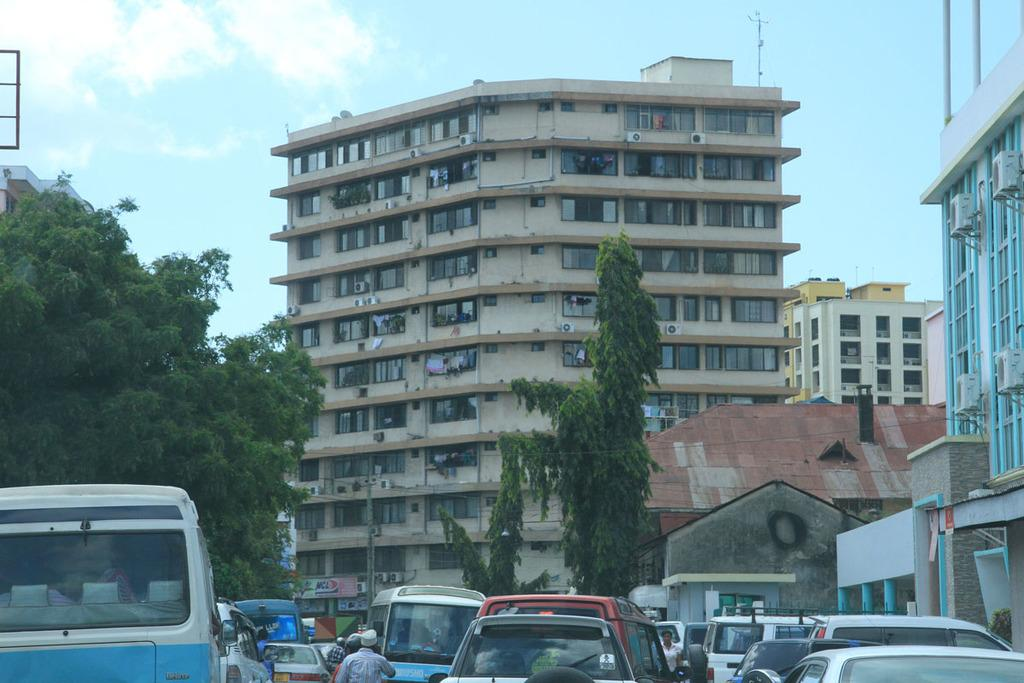What type of structures can be seen in the image? There are buildings in the image. What else can be seen moving in the image? There are vehicles in the image. Are there any people present in the image? Yes, there are persons in the image. What type of natural elements can be seen in the image? There are trees in the image. What type of appliances can be seen in the image? There are air conditioners in the image. What type of openings can be seen in the buildings? There are windows in the image. What type of vertical structures can be seen in the image? There are poles in the image. What part of the environment is visible in the image? The sky is visible in the image. Can you see a girl writing in a notebook in the image? There is no girl or notebook present in the image. 